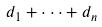Convert formula to latex. <formula><loc_0><loc_0><loc_500><loc_500>d _ { 1 } + \cdot \cdot \cdot + d _ { n }</formula> 